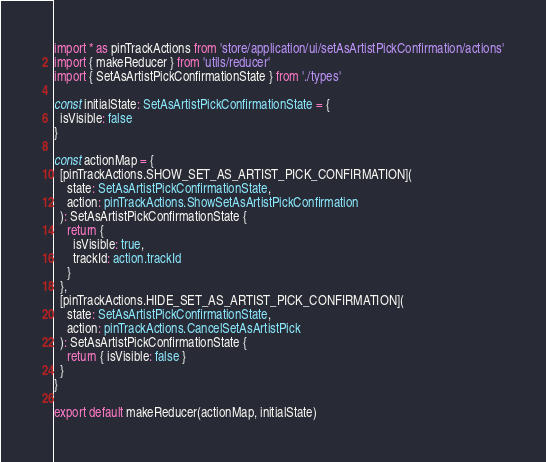<code> <loc_0><loc_0><loc_500><loc_500><_TypeScript_>import * as pinTrackActions from 'store/application/ui/setAsArtistPickConfirmation/actions'
import { makeReducer } from 'utils/reducer'
import { SetAsArtistPickConfirmationState } from './types'

const initialState: SetAsArtistPickConfirmationState = {
  isVisible: false
}

const actionMap = {
  [pinTrackActions.SHOW_SET_AS_ARTIST_PICK_CONFIRMATION](
    state: SetAsArtistPickConfirmationState,
    action: pinTrackActions.ShowSetAsArtistPickConfirmation
  ): SetAsArtistPickConfirmationState {
    return {
      isVisible: true,
      trackId: action.trackId
    }
  },
  [pinTrackActions.HIDE_SET_AS_ARTIST_PICK_CONFIRMATION](
    state: SetAsArtistPickConfirmationState,
    action: pinTrackActions.CancelSetAsArtistPick
  ): SetAsArtistPickConfirmationState {
    return { isVisible: false }
  }
}

export default makeReducer(actionMap, initialState)
</code> 